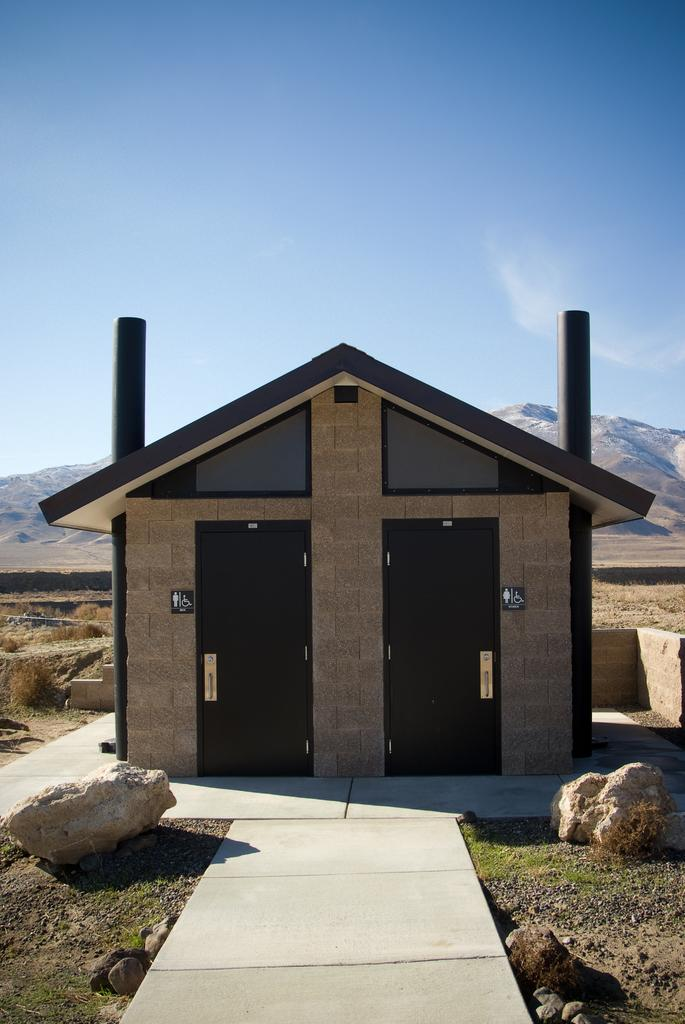What type of structure is present in the image? There is a house in the image. What features can be seen on the house? The house has doors and boards. What natural elements are present in the image? There are rocks, plants, and hills in the image. What is visible in the background of the image? The sky is visible in the background of the image. What type of joke is being told by the porter in the image? There is no porter present in the image, nor is there any indication of a joke being told. 